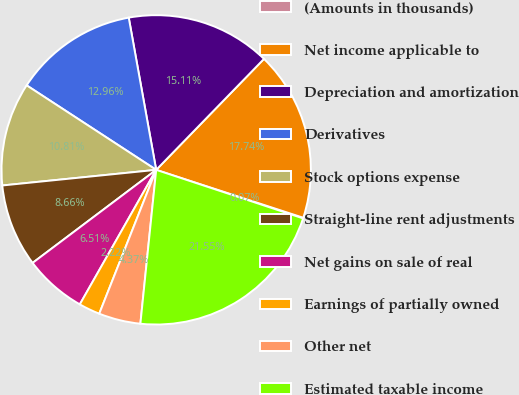Convert chart. <chart><loc_0><loc_0><loc_500><loc_500><pie_chart><fcel>(Amounts in thousands)<fcel>Net income applicable to<fcel>Depreciation and amortization<fcel>Derivatives<fcel>Stock options expense<fcel>Straight-line rent adjustments<fcel>Net gains on sale of real<fcel>Earnings of partially owned<fcel>Other net<fcel>Estimated taxable income<nl><fcel>0.07%<fcel>17.74%<fcel>15.11%<fcel>12.96%<fcel>10.81%<fcel>8.66%<fcel>6.51%<fcel>2.22%<fcel>4.37%<fcel>21.55%<nl></chart> 